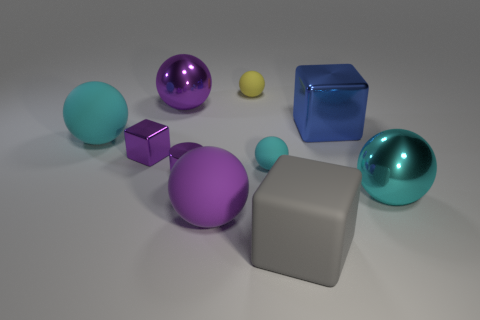Subtract all red spheres. Subtract all brown cubes. How many spheres are left? 6 Subtract all blue cylinders. How many cyan cubes are left? 0 Add 3 cyans. How many blues exist? 0 Subtract all matte cubes. Subtract all metallic balls. How many objects are left? 7 Add 2 small cubes. How many small cubes are left? 3 Add 2 red cylinders. How many red cylinders exist? 2 Subtract all yellow spheres. How many spheres are left? 5 Subtract all big purple metallic spheres. How many spheres are left? 5 Subtract 1 gray blocks. How many objects are left? 9 Subtract all cyan balls. How many were subtracted if there are1cyan balls left? 2 